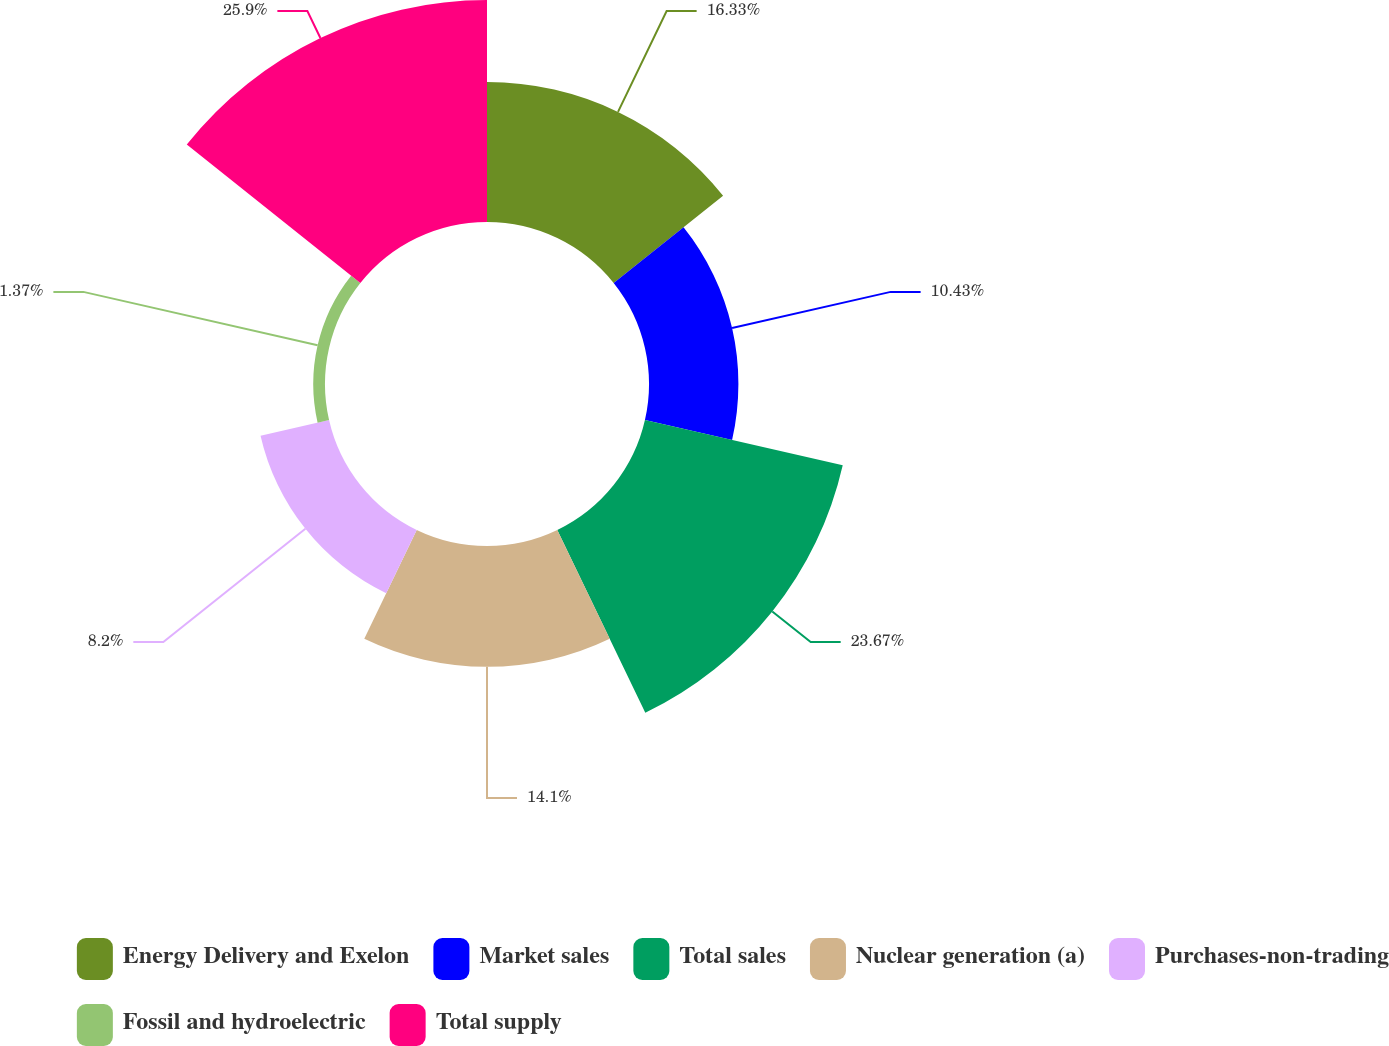Convert chart. <chart><loc_0><loc_0><loc_500><loc_500><pie_chart><fcel>Energy Delivery and Exelon<fcel>Market sales<fcel>Total sales<fcel>Nuclear generation (a)<fcel>Purchases-non-trading<fcel>Fossil and hydroelectric<fcel>Total supply<nl><fcel>16.33%<fcel>10.43%<fcel>23.67%<fcel>14.1%<fcel>8.2%<fcel>1.37%<fcel>25.9%<nl></chart> 